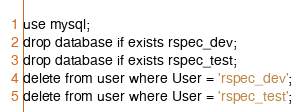Convert code to text. <code><loc_0><loc_0><loc_500><loc_500><_SQL_>use mysql;
drop database if exists rspec_dev;
drop database if exists rspec_test;
delete from user where User = 'rspec_dev';
delete from user where User = 'rspec_test';</code> 